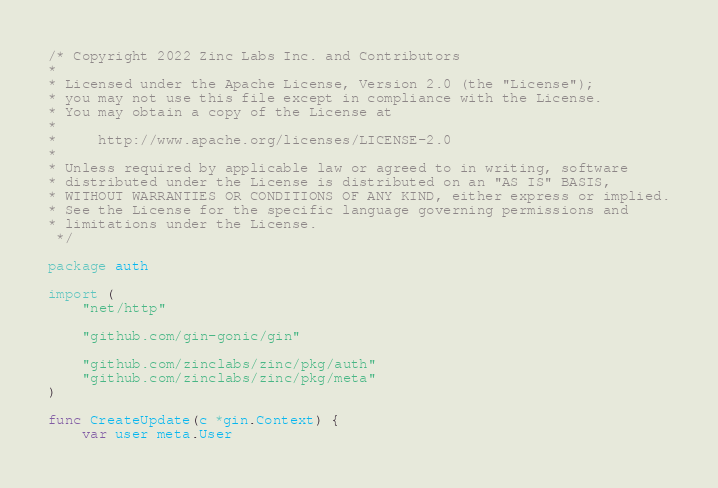Convert code to text. <code><loc_0><loc_0><loc_500><loc_500><_Go_>/* Copyright 2022 Zinc Labs Inc. and Contributors
*
* Licensed under the Apache License, Version 2.0 (the "License");
* you may not use this file except in compliance with the License.
* You may obtain a copy of the License at
*
*     http://www.apache.org/licenses/LICENSE-2.0
*
* Unless required by applicable law or agreed to in writing, software
* distributed under the License is distributed on an "AS IS" BASIS,
* WITHOUT WARRANTIES OR CONDITIONS OF ANY KIND, either express or implied.
* See the License for the specific language governing permissions and
* limitations under the License.
 */

package auth

import (
	"net/http"

	"github.com/gin-gonic/gin"

	"github.com/zinclabs/zinc/pkg/auth"
	"github.com/zinclabs/zinc/pkg/meta"
)

func CreateUpdate(c *gin.Context) {
	var user meta.User</code> 